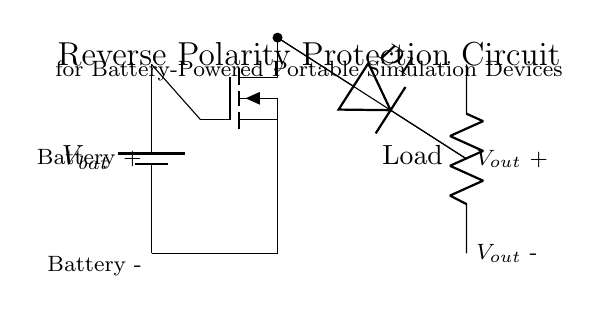What type of transistor is used in this circuit? The circuit uses an N-channel MOSFET, as indicated by the symbol and the labeling of the component in the diagram.
Answer: N-channel MOSFET What is the function of the diode in this circuit? The diode allows current to flow in only one direction, preventing reverse polarity from reaching the load if the battery is connected incorrectly.
Answer: Prevents reverse current How many components are connected in series in this circuit? There are three components connected in series: the MOSFET, the diode, and the load resistor. The battery is connected to the entire arrangement, but the intermediate components follow a series configuration.
Answer: Three What is the potential difference at the output when the correct polarity is applied? When the correct polarity is applied, the voltage at the output is equal to the battery voltage minus the forward voltage drop across the diode, which is nominally low but can vary. However, the graph helps indicate that it maintains the voltage flowing through.
Answer: Battery voltage minus diode drop What happens if the battery is connected with reverse polarity? If the battery is connected with reverse polarity, the diode will be reverse-biased, effectively blocking the current flow and protecting the load from damage.
Answer: Current is blocked What is the role of the MOSFET in this reverse polarity protection circuit? The MOSFET acts as a switch that can control the flow of current based on the voltage applied to its gate. With correct polarity, it turns on, allowing current to flow; with reverse polarity, it remains off, ensuring no current flows to the load.
Answer: Acts as a switch What would happen to the load if the MOSFET were replaced with a standard diode? If the MOSFET were replaced with a standard diode, the circuit would not have low on-resistance and might lead to a significant forward voltage drop, causing inefficient performance or insufficient voltage at the load.
Answer: Increased voltage drop 